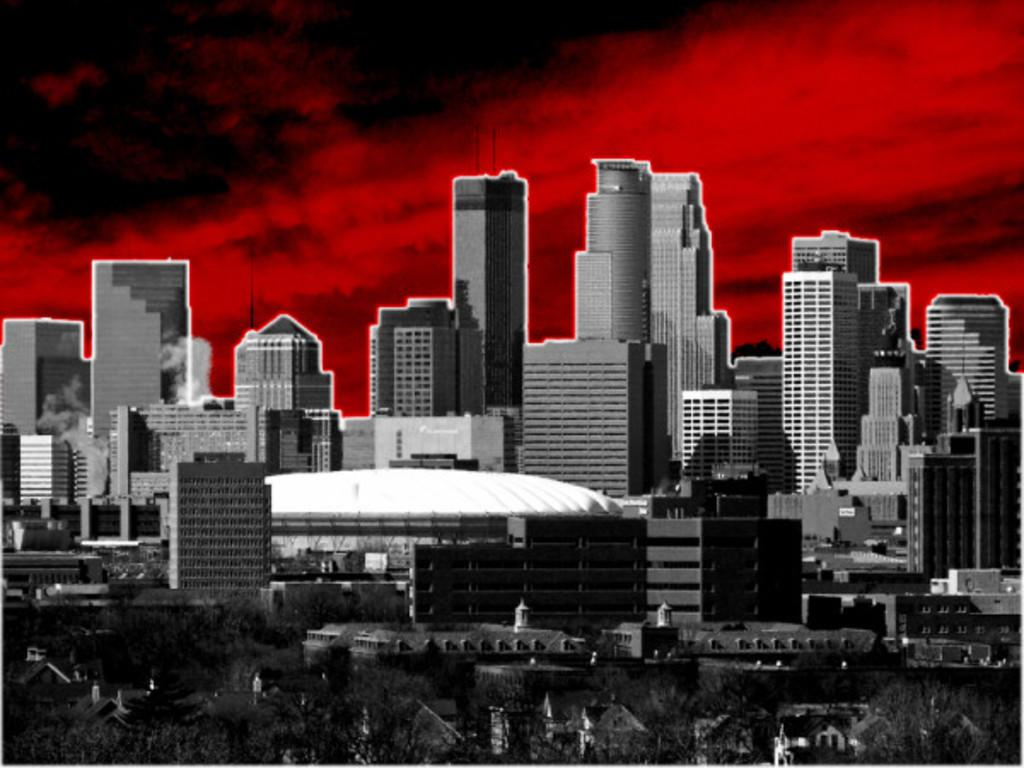What type of structure is depicted in the edited picture? The image contains an edited picture of a group of buildings. What features can be observed on the buildings? The buildings have windows and roofs. What other elements are present in the image besides the buildings? There is a group of trees in the image. What can be seen in the background of the image? The sky is visible in the background of the image. Can you see a robin perched on one of the buildings in the image? There is no robin present in the image; it only features a group of buildings, trees, and the sky. What type of flesh can be seen on the buildings in the image? The buildings in the image are made of inanimate materials, such as concrete or brick, and do not have any flesh. 